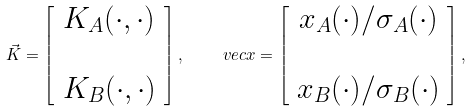Convert formula to latex. <formula><loc_0><loc_0><loc_500><loc_500>\vec { K } = \left [ \begin{array} { c } K _ { A } ( \cdot , \cdot ) \\ \\ K _ { B } ( \cdot , \cdot ) \end{array} \right ] , \ \quad v e c { x } = \left [ \begin{array} { c } x _ { A } ( \cdot ) / \sigma _ { A } ( \cdot ) \\ \\ x _ { B } ( \cdot ) / \sigma _ { B } ( \cdot ) \end{array} \right ] ,</formula> 